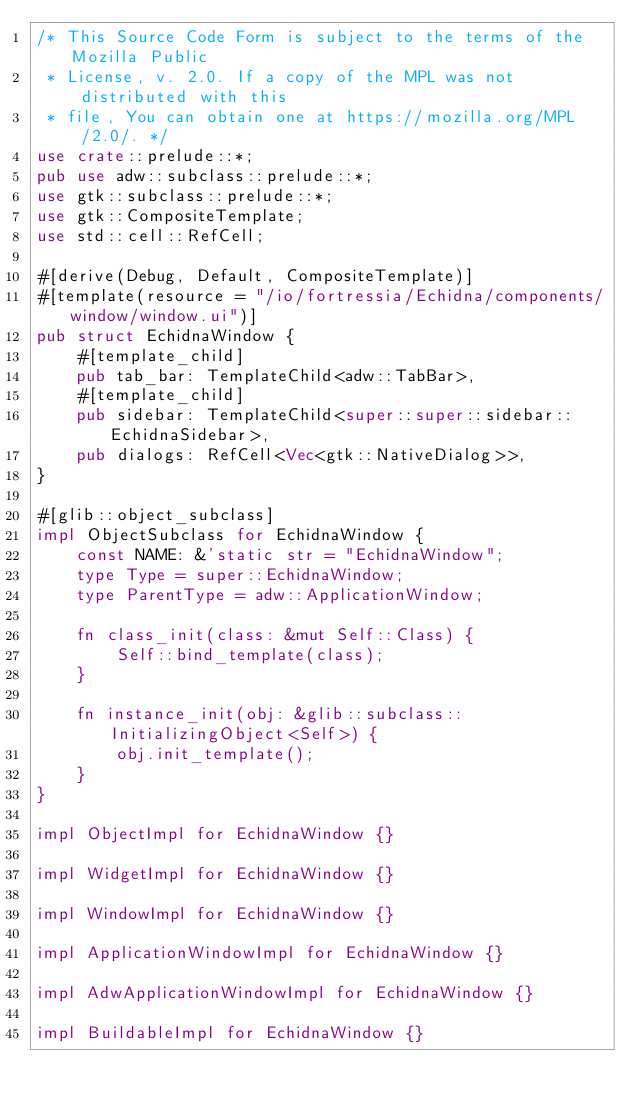Convert code to text. <code><loc_0><loc_0><loc_500><loc_500><_Rust_>/* This Source Code Form is subject to the terms of the Mozilla Public
 * License, v. 2.0. If a copy of the MPL was not distributed with this
 * file, You can obtain one at https://mozilla.org/MPL/2.0/. */
use crate::prelude::*;
pub use adw::subclass::prelude::*;
use gtk::subclass::prelude::*;
use gtk::CompositeTemplate;
use std::cell::RefCell;

#[derive(Debug, Default, CompositeTemplate)]
#[template(resource = "/io/fortressia/Echidna/components/window/window.ui")]
pub struct EchidnaWindow {
    #[template_child]
    pub tab_bar: TemplateChild<adw::TabBar>,
    #[template_child]
    pub sidebar: TemplateChild<super::super::sidebar::EchidnaSidebar>,
    pub dialogs: RefCell<Vec<gtk::NativeDialog>>,
}

#[glib::object_subclass]
impl ObjectSubclass for EchidnaWindow {
    const NAME: &'static str = "EchidnaWindow";
    type Type = super::EchidnaWindow;
    type ParentType = adw::ApplicationWindow;

    fn class_init(class: &mut Self::Class) {
        Self::bind_template(class);
    }

    fn instance_init(obj: &glib::subclass::InitializingObject<Self>) {
        obj.init_template();
    }
}

impl ObjectImpl for EchidnaWindow {}

impl WidgetImpl for EchidnaWindow {}

impl WindowImpl for EchidnaWindow {}

impl ApplicationWindowImpl for EchidnaWindow {}

impl AdwApplicationWindowImpl for EchidnaWindow {}

impl BuildableImpl for EchidnaWindow {}
</code> 